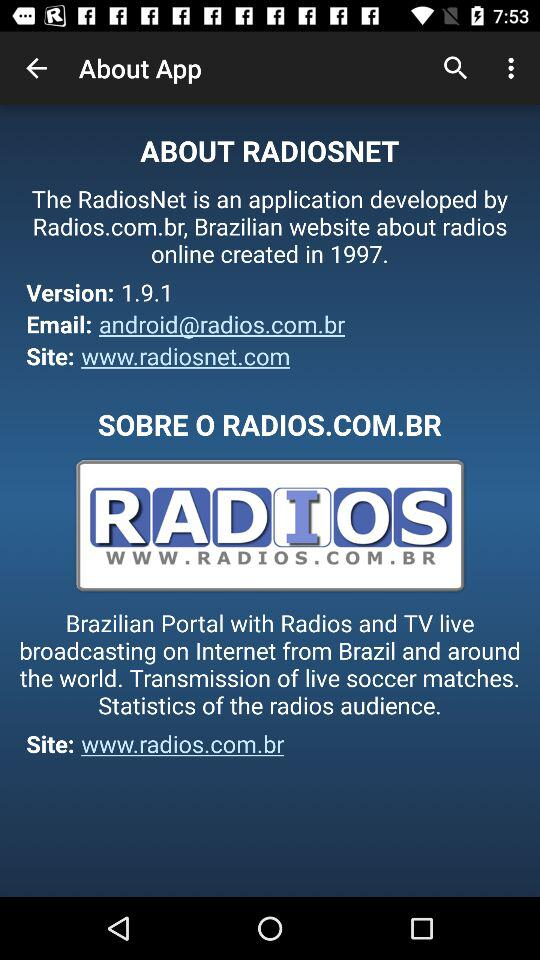In which year was the website about radios online created? The website was created in 1997. 